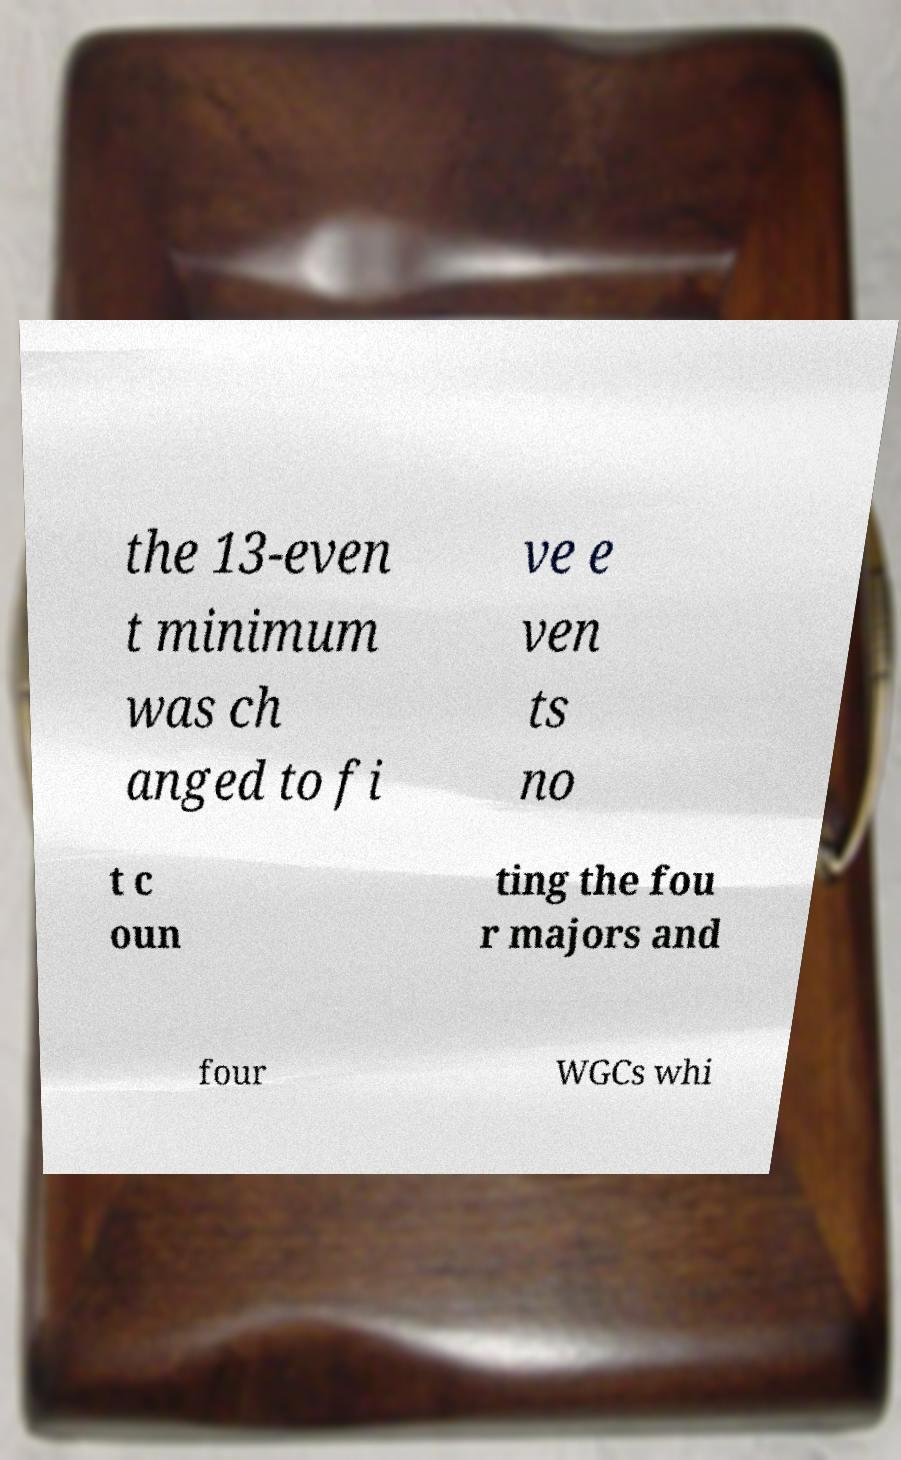Can you read and provide the text displayed in the image?This photo seems to have some interesting text. Can you extract and type it out for me? the 13-even t minimum was ch anged to fi ve e ven ts no t c oun ting the fou r majors and four WGCs whi 